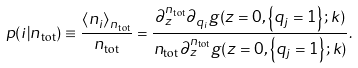Convert formula to latex. <formula><loc_0><loc_0><loc_500><loc_500>p ( i | n _ { \text {tot} } ) \equiv \frac { \left \langle n _ { i } \right \rangle _ { n _ { \text {tot} } } } { n _ { \text {tot} } } = \frac { \partial _ { z } ^ { n _ { \text {tot} } } \partial _ { q _ { i } } g ( z = 0 , \left \{ q _ { j } = 1 \right \} ; k ) } { n _ { \text {tot} } \partial _ { z } ^ { n _ { \text {tot} } } g ( z = 0 , \left \{ q _ { j } = 1 \right \} ; k ) } .</formula> 